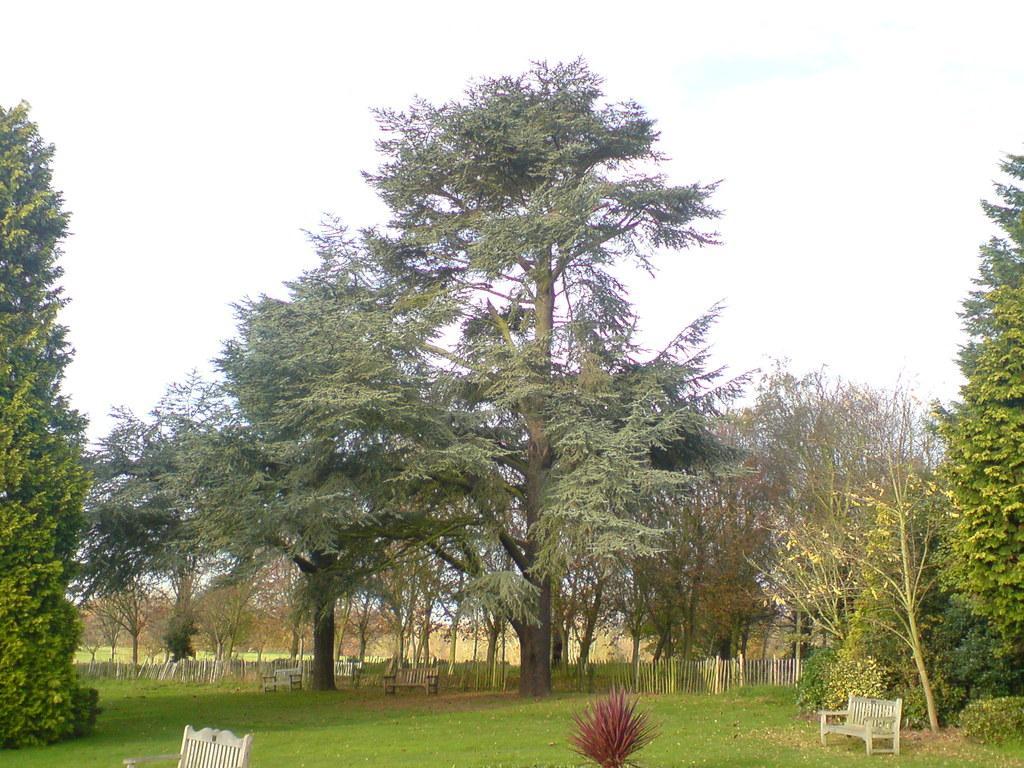Could you give a brief overview of what you see in this image? In the foreground of the image we can see grass and benches. In the middle of the image we can see trees. On the top of the image we can see the sky. 